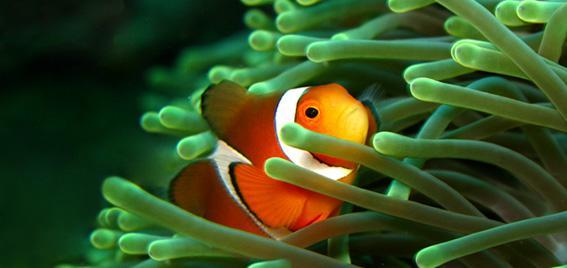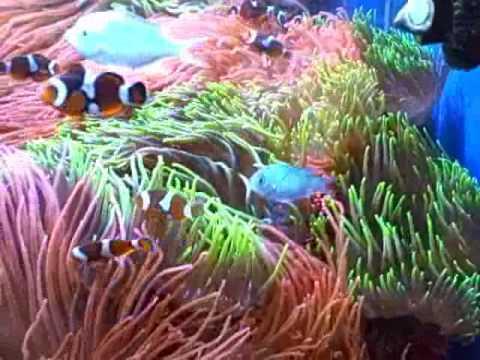The first image is the image on the left, the second image is the image on the right. Examine the images to the left and right. Is the description "There are at most three clownfish swimming." accurate? Answer yes or no. No. 